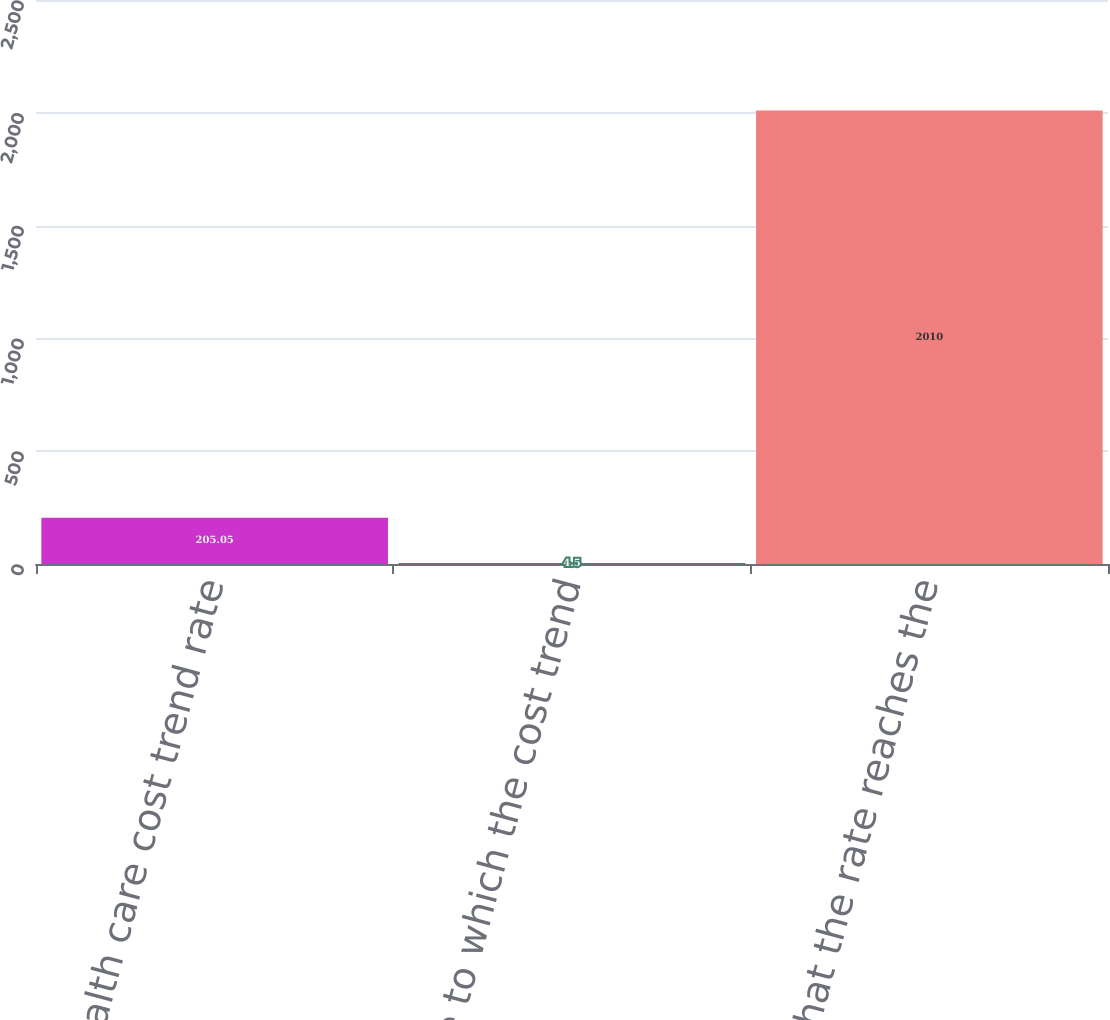<chart> <loc_0><loc_0><loc_500><loc_500><bar_chart><fcel>Health care cost trend rate<fcel>Rate to which the cost trend<fcel>Year that the rate reaches the<nl><fcel>205.05<fcel>4.5<fcel>2010<nl></chart> 